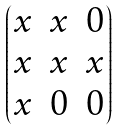<formula> <loc_0><loc_0><loc_500><loc_500>\begin{pmatrix} x & x & 0 \\ x & x & x \\ x & 0 & 0 \\ \end{pmatrix}</formula> 